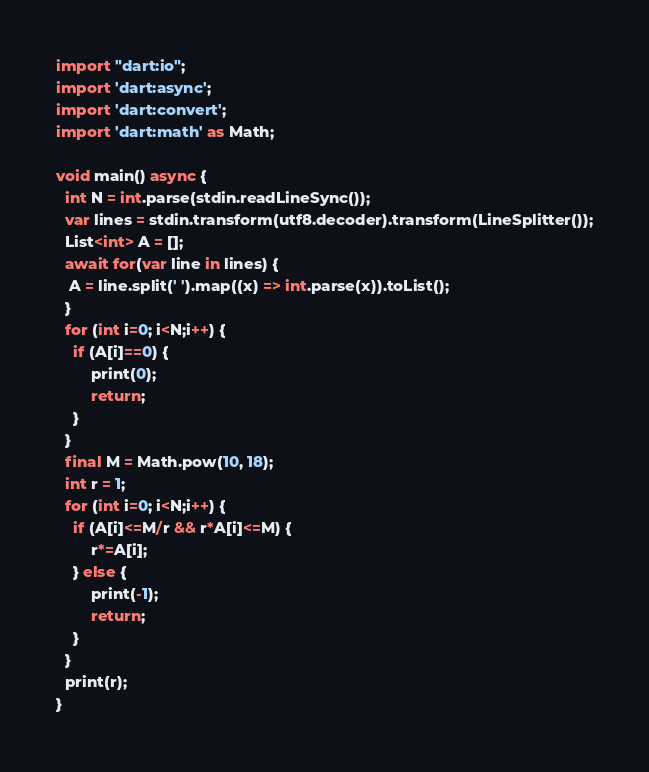Convert code to text. <code><loc_0><loc_0><loc_500><loc_500><_Dart_>import "dart:io";
import 'dart:async';
import 'dart:convert';
import 'dart:math' as Math;

void main() async {
  int N = int.parse(stdin.readLineSync());
  var lines = stdin.transform(utf8.decoder).transform(LineSplitter());
  List<int> A = [];
  await for(var line in lines) {
   A = line.split(' ').map((x) => int.parse(x)).toList();
  }
  for (int i=0; i<N;i++) {
  	if (A[i]==0) {
    	print(0);
        return;
    }
  }
  final M = Math.pow(10, 18);
  int r = 1;
  for (int i=0; i<N;i++) {
    if (A[i]<=M/r && r*A[i]<=M) {
    	r*=A[i];
    } else {
     	print(-1);
      	return;
    }
  }
  print(r);
}
</code> 